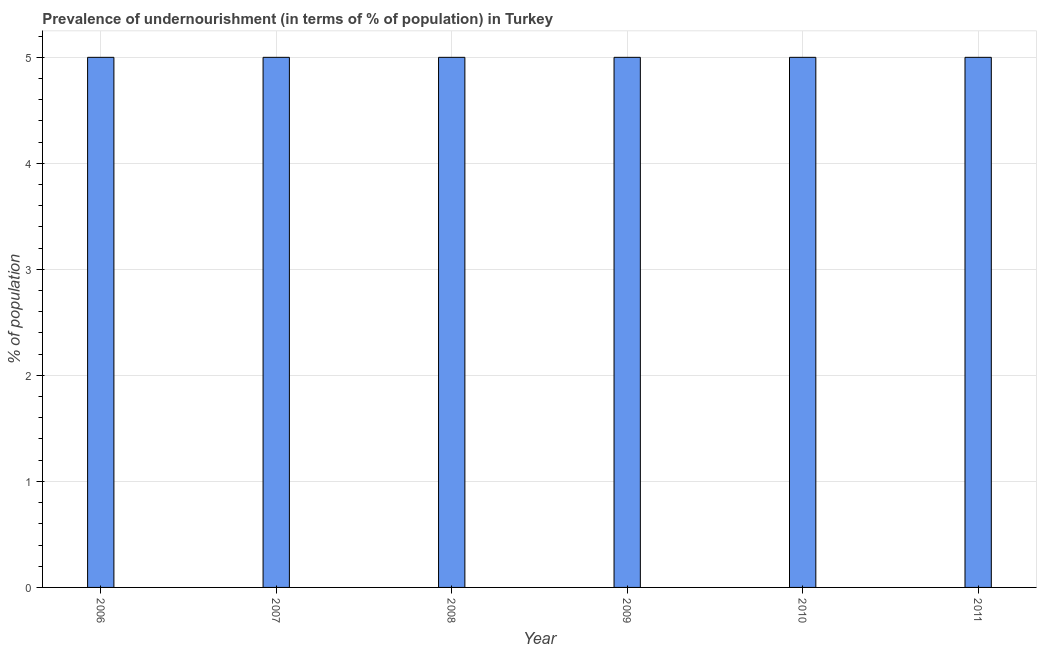What is the title of the graph?
Give a very brief answer. Prevalence of undernourishment (in terms of % of population) in Turkey. What is the label or title of the X-axis?
Make the answer very short. Year. What is the label or title of the Y-axis?
Keep it short and to the point. % of population. What is the percentage of undernourished population in 2010?
Ensure brevity in your answer.  5. Across all years, what is the maximum percentage of undernourished population?
Make the answer very short. 5. Across all years, what is the minimum percentage of undernourished population?
Give a very brief answer. 5. What is the sum of the percentage of undernourished population?
Provide a succinct answer. 30. What is the difference between the percentage of undernourished population in 2007 and 2011?
Offer a very short reply. 0. What is the median percentage of undernourished population?
Your answer should be compact. 5. Is the percentage of undernourished population in 2007 less than that in 2008?
Your response must be concise. No. What is the difference between the highest and the second highest percentage of undernourished population?
Offer a very short reply. 0. How many bars are there?
Make the answer very short. 6. How many years are there in the graph?
Your answer should be very brief. 6. What is the difference between two consecutive major ticks on the Y-axis?
Provide a short and direct response. 1. Are the values on the major ticks of Y-axis written in scientific E-notation?
Give a very brief answer. No. What is the % of population of 2007?
Your answer should be compact. 5. What is the % of population of 2008?
Offer a very short reply. 5. What is the % of population in 2009?
Offer a terse response. 5. What is the % of population in 2010?
Provide a succinct answer. 5. What is the % of population of 2011?
Your answer should be compact. 5. What is the difference between the % of population in 2006 and 2008?
Offer a terse response. 0. What is the difference between the % of population in 2006 and 2011?
Keep it short and to the point. 0. What is the difference between the % of population in 2007 and 2009?
Provide a succinct answer. 0. What is the difference between the % of population in 2007 and 2010?
Your response must be concise. 0. What is the difference between the % of population in 2007 and 2011?
Your answer should be very brief. 0. What is the difference between the % of population in 2008 and 2011?
Make the answer very short. 0. What is the difference between the % of population in 2009 and 2011?
Give a very brief answer. 0. What is the difference between the % of population in 2010 and 2011?
Give a very brief answer. 0. What is the ratio of the % of population in 2006 to that in 2008?
Give a very brief answer. 1. What is the ratio of the % of population in 2006 to that in 2009?
Give a very brief answer. 1. What is the ratio of the % of population in 2006 to that in 2010?
Make the answer very short. 1. What is the ratio of the % of population in 2007 to that in 2010?
Your answer should be compact. 1. What is the ratio of the % of population in 2008 to that in 2010?
Your answer should be compact. 1. What is the ratio of the % of population in 2008 to that in 2011?
Offer a terse response. 1. What is the ratio of the % of population in 2009 to that in 2011?
Your response must be concise. 1. What is the ratio of the % of population in 2010 to that in 2011?
Offer a terse response. 1. 